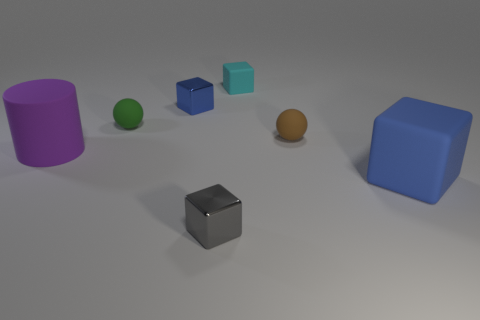There is a object that is the same color as the large block; what size is it?
Provide a short and direct response. Small. Is there a brown ball that has the same material as the cylinder?
Provide a succinct answer. Yes. Does the small green thing have the same material as the small brown object?
Your response must be concise. Yes. There is a big object in front of the purple cylinder; what number of small metal objects are behind it?
Make the answer very short. 1. How many green things are rubber cylinders or cubes?
Your response must be concise. 0. What shape is the brown rubber thing that is on the right side of the large object to the left of the tiny metallic cube that is in front of the big blue object?
Ensure brevity in your answer.  Sphere. What is the color of the matte block that is the same size as the brown ball?
Give a very brief answer. Cyan. What number of tiny green things have the same shape as the small brown rubber object?
Make the answer very short. 1. Do the purple thing and the blue thing that is to the right of the tiny cyan thing have the same size?
Offer a terse response. Yes. There is a blue metal thing that is behind the tiny cube that is in front of the brown matte sphere; what shape is it?
Offer a terse response. Cube. 